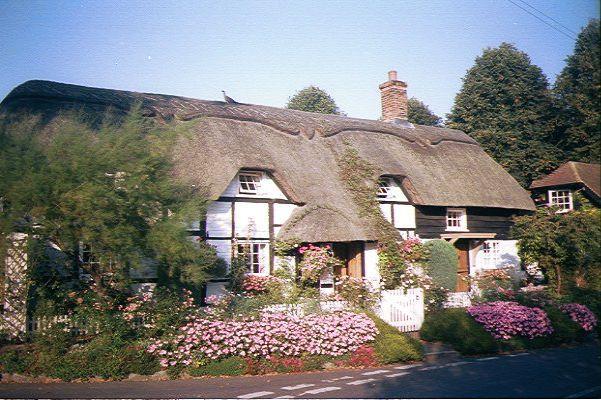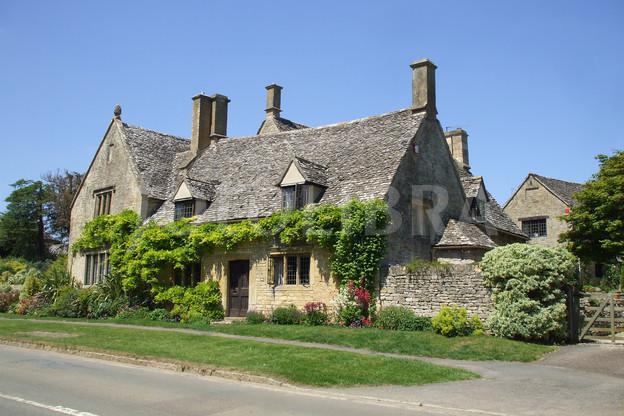The first image is the image on the left, the second image is the image on the right. Examine the images to the left and right. Is the description "The left image shows the front of a white house with bold dark lines on it forming geometric patterns, a chimney on at least one end, and a thick grayish peaked roof with a sculptural border along the top edge." accurate? Answer yes or no. Yes. The first image is the image on the left, the second image is the image on the right. For the images displayed, is the sentence "In at least one image there is a white house with black stripes of wood that create a box look." factually correct? Answer yes or no. Yes. 